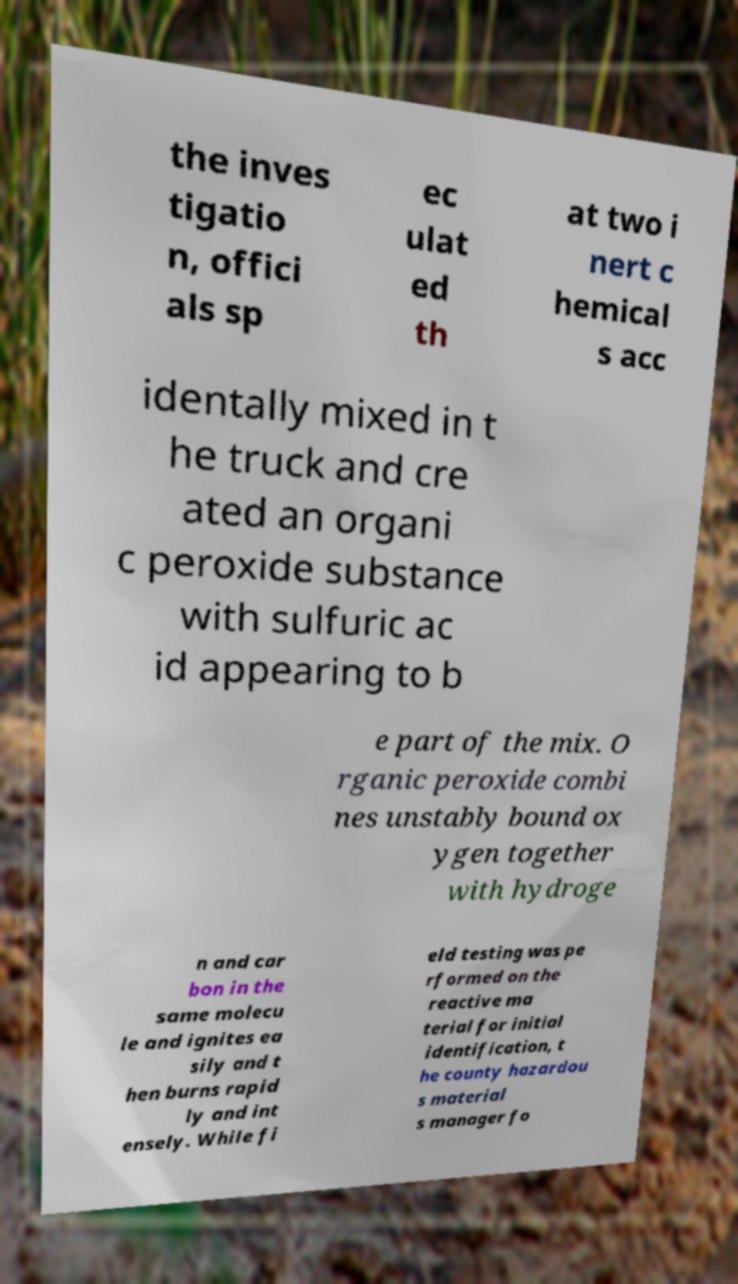Could you assist in decoding the text presented in this image and type it out clearly? the inves tigatio n, offici als sp ec ulat ed th at two i nert c hemical s acc identally mixed in t he truck and cre ated an organi c peroxide substance with sulfuric ac id appearing to b e part of the mix. O rganic peroxide combi nes unstably bound ox ygen together with hydroge n and car bon in the same molecu le and ignites ea sily and t hen burns rapid ly and int ensely. While fi eld testing was pe rformed on the reactive ma terial for initial identification, t he county hazardou s material s manager fo 